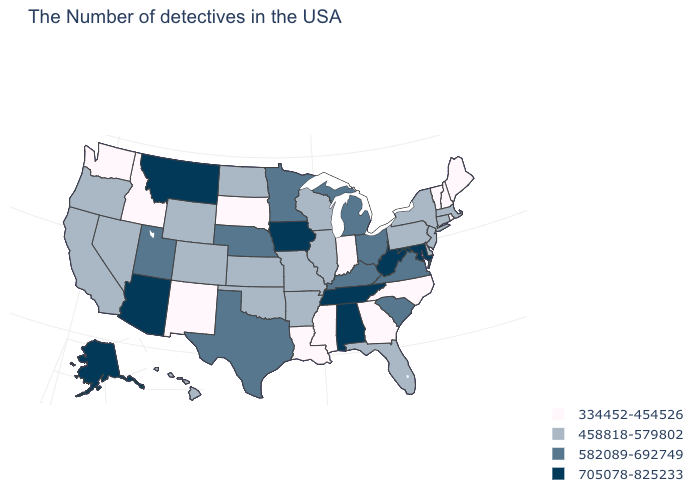What is the lowest value in the MidWest?
Concise answer only. 334452-454526. What is the value of Maine?
Write a very short answer. 334452-454526. What is the lowest value in the West?
Answer briefly. 334452-454526. Name the states that have a value in the range 582089-692749?
Concise answer only. Virginia, South Carolina, Ohio, Michigan, Kentucky, Minnesota, Nebraska, Texas, Utah. Does the first symbol in the legend represent the smallest category?
Be succinct. Yes. Does South Dakota have the lowest value in the MidWest?
Be succinct. Yes. Name the states that have a value in the range 705078-825233?
Answer briefly. Maryland, West Virginia, Alabama, Tennessee, Iowa, Montana, Arizona, Alaska. Name the states that have a value in the range 334452-454526?
Concise answer only. Maine, Rhode Island, New Hampshire, Vermont, North Carolina, Georgia, Indiana, Mississippi, Louisiana, South Dakota, New Mexico, Idaho, Washington. Name the states that have a value in the range 334452-454526?
Concise answer only. Maine, Rhode Island, New Hampshire, Vermont, North Carolina, Georgia, Indiana, Mississippi, Louisiana, South Dakota, New Mexico, Idaho, Washington. Among the states that border Montana , does Idaho have the lowest value?
Concise answer only. Yes. What is the value of Rhode Island?
Answer briefly. 334452-454526. What is the lowest value in states that border Oklahoma?
Give a very brief answer. 334452-454526. What is the lowest value in the USA?
Short answer required. 334452-454526. Does Maryland have a lower value than North Dakota?
Quick response, please. No. Which states have the lowest value in the MidWest?
Write a very short answer. Indiana, South Dakota. 